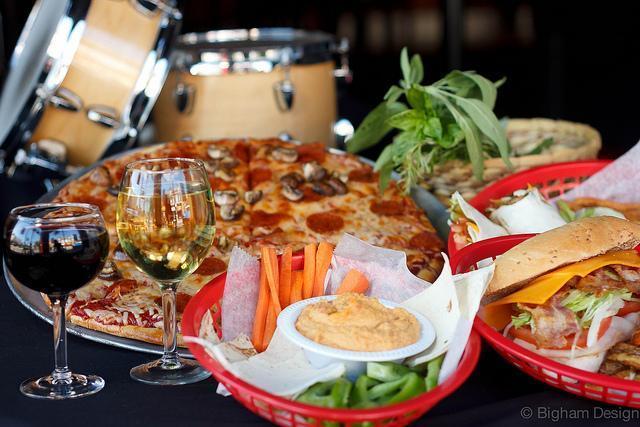Is the statement "The pizza is behind the sandwich." accurate regarding the image?
Answer yes or no. Yes. 